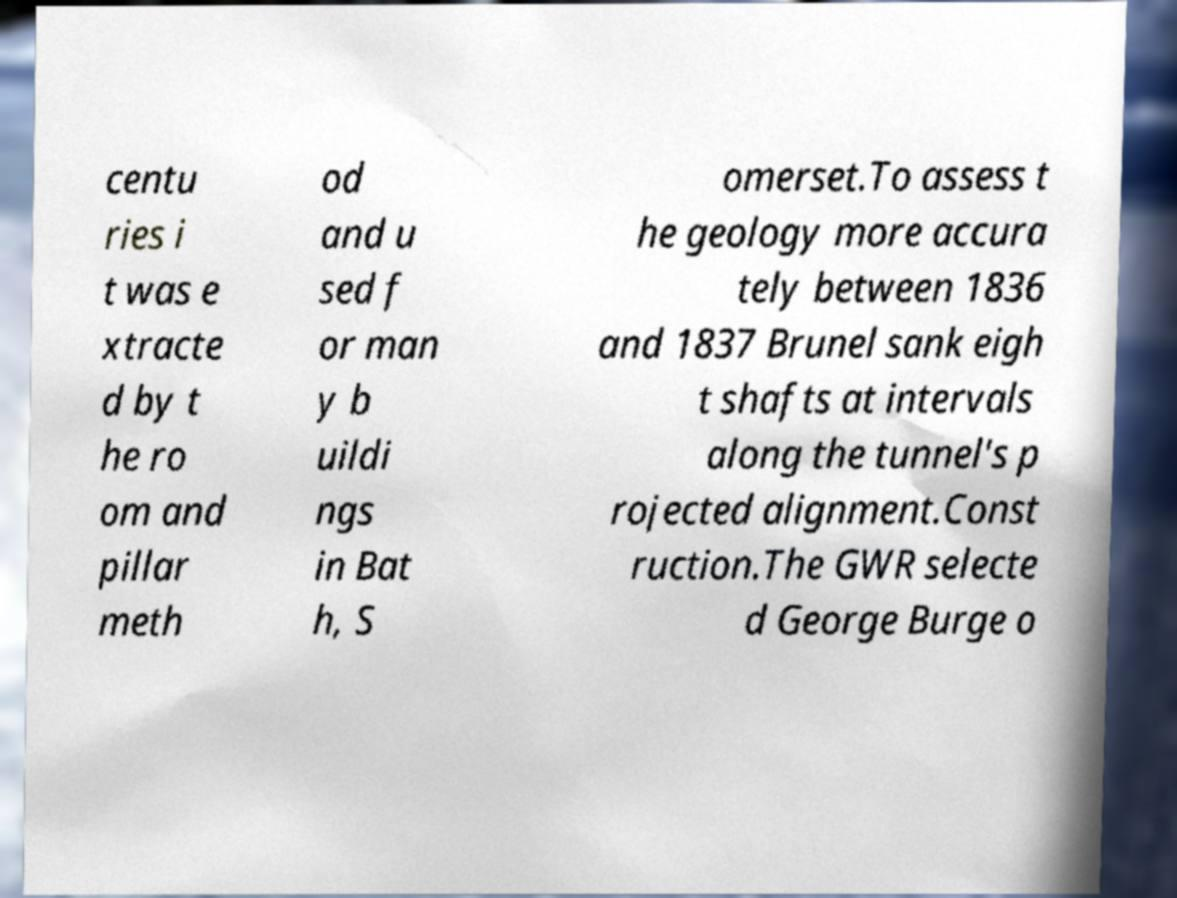Could you extract and type out the text from this image? centu ries i t was e xtracte d by t he ro om and pillar meth od and u sed f or man y b uildi ngs in Bat h, S omerset.To assess t he geology more accura tely between 1836 and 1837 Brunel sank eigh t shafts at intervals along the tunnel's p rojected alignment.Const ruction.The GWR selecte d George Burge o 